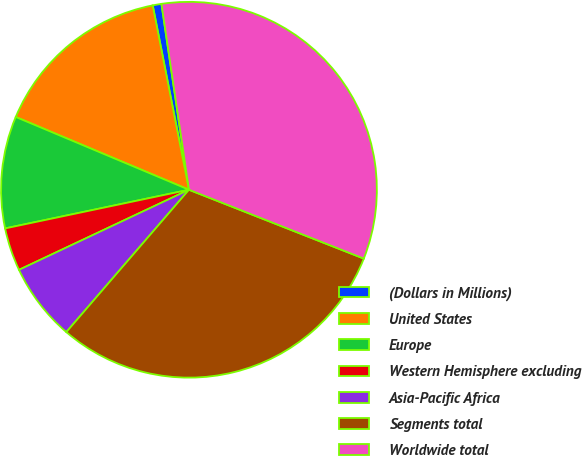Convert chart to OTSL. <chart><loc_0><loc_0><loc_500><loc_500><pie_chart><fcel>(Dollars in Millions)<fcel>United States<fcel>Europe<fcel>Western Hemisphere excluding<fcel>Asia-Pacific Africa<fcel>Segments total<fcel>Worldwide total<nl><fcel>0.75%<fcel>15.58%<fcel>9.63%<fcel>3.71%<fcel>6.67%<fcel>30.35%<fcel>33.31%<nl></chart> 